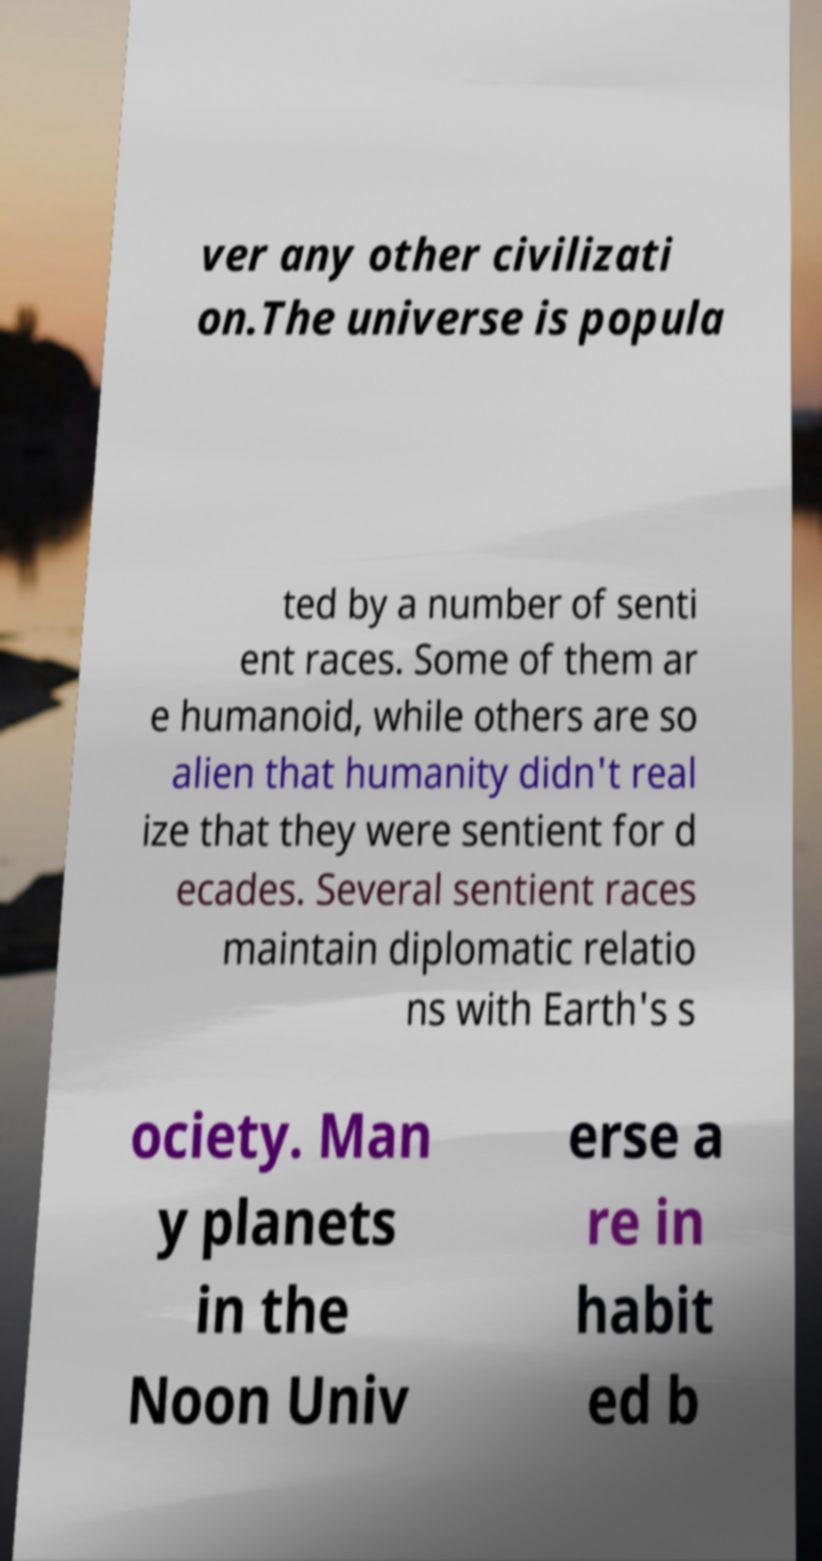Can you read and provide the text displayed in the image?This photo seems to have some interesting text. Can you extract and type it out for me? ver any other civilizati on.The universe is popula ted by a number of senti ent races. Some of them ar e humanoid, while others are so alien that humanity didn't real ize that they were sentient for d ecades. Several sentient races maintain diplomatic relatio ns with Earth's s ociety. Man y planets in the Noon Univ erse a re in habit ed b 